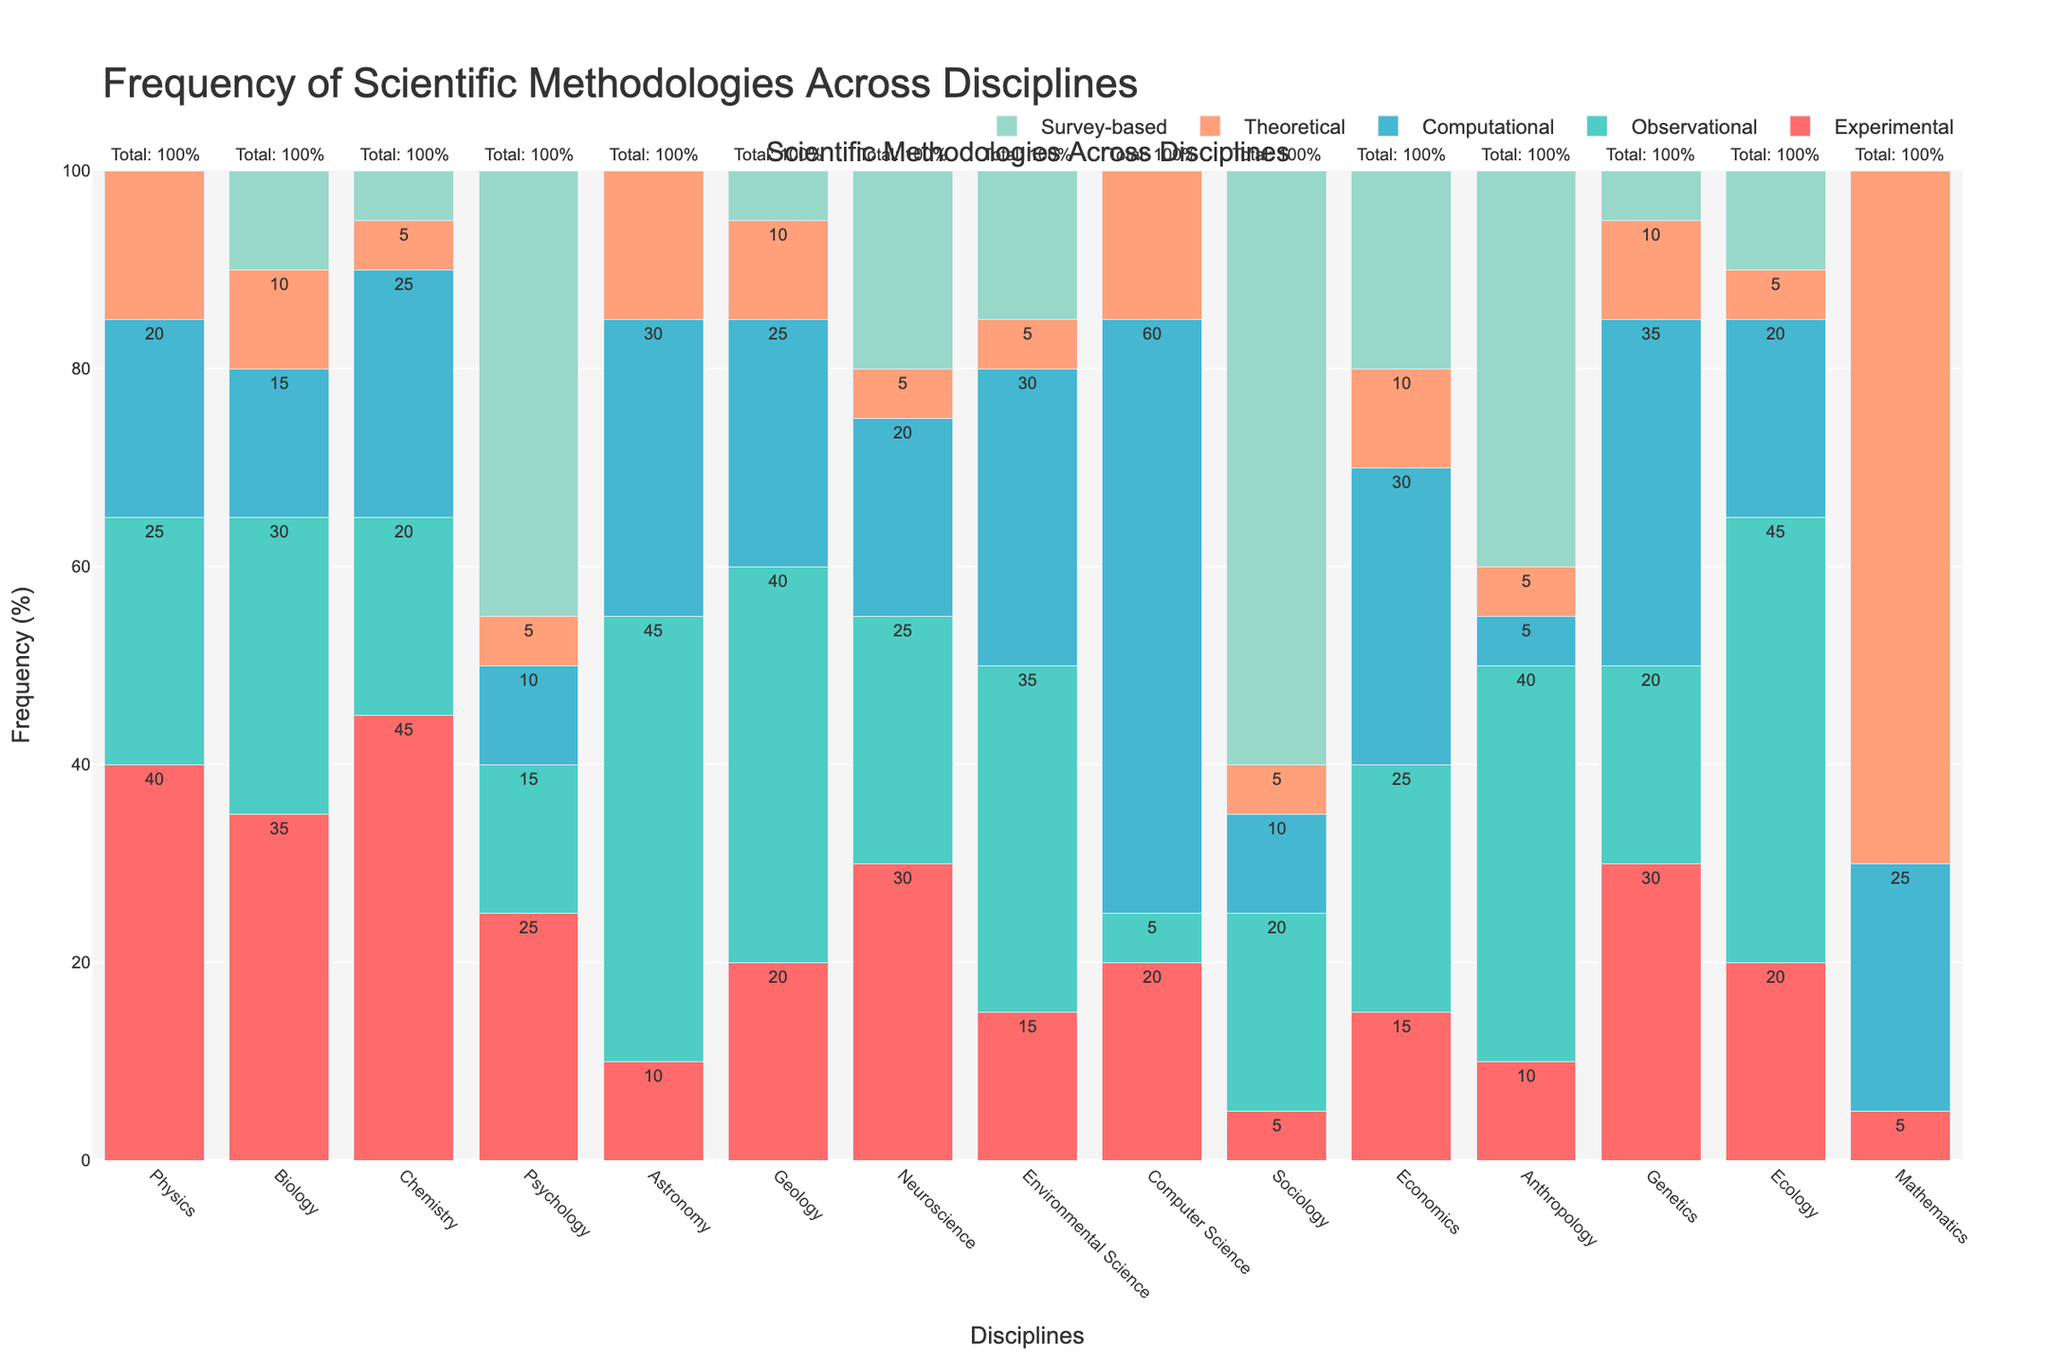Which discipline has the highest frequency of experimental methods? By looking at the heights of the red bars representing experimental methods, Chemistry has the highest with a value of 45%.
Answer: Chemistry Which discipline has the highest combined frequency of observational and theoretical methodologies? Observational (green) and theoretical (orange) methodologies need to be combined for each discipline. For Mathematics: 0 (Observational) + 70 (Theoretical) = 70. This is the highest combined frequency compared to other disciplines.
Answer: Mathematics What is the average frequency of survey-based methods across all disciplines? Add up all the frequencies for survey-based methods (grey bars) and divide by the number of disciplines: (0 + 10 + 5 + 45 + 0 + 5 + 20 + 15 + 0 + 60 + 20 + 40 + 5 + 10 + 0) / 15 = 235 / 15 = 15.67.
Answer: 15.67 Compare the frequency of observational methodologies in Astronomy and Ecology. Observational methods are represented by green bars. For Astronomy: 45, and for Ecology: 45. They are equal.
Answer: Equal Which discipline has the lowest total frequency of methodologies? By looking at the total percentage of methodologies for each discipline (sum of all colored bars), Mathematics has the lowest with a total of 100%.
Answer: Mathematics Which methodology is least frequently used in Computer Science? By examining the different colored bars for Computer Science, survey-based methods (grey) have a frequency of 0%, which is the least.
Answer: Survey-based What is the sum of the frequencies of computational methods in Biology, Chemistry, and Computer Science? Add the frequencies of computational methods (blue bars) in Biology: 15, Chemistry: 25, and Computer Science: 60. Total: 15 + 25 + 60 = 100.
Answer: 100 In which two disciplines is the frequency of observational methods equal, and what is that frequency? Look for disciplines where the green bars are of equal height. Astronomy and Ecology both have a frequency of 45 in observational methods.
Answer: Astronomy and Ecology, 45 What is the frequency difference between theoretical methods in Physics and Genetics? Theoretical methods (orange bars) in Physics is 15 and in Genetics is 10. Difference: 15 - 10 = 5.
Answer: 5 